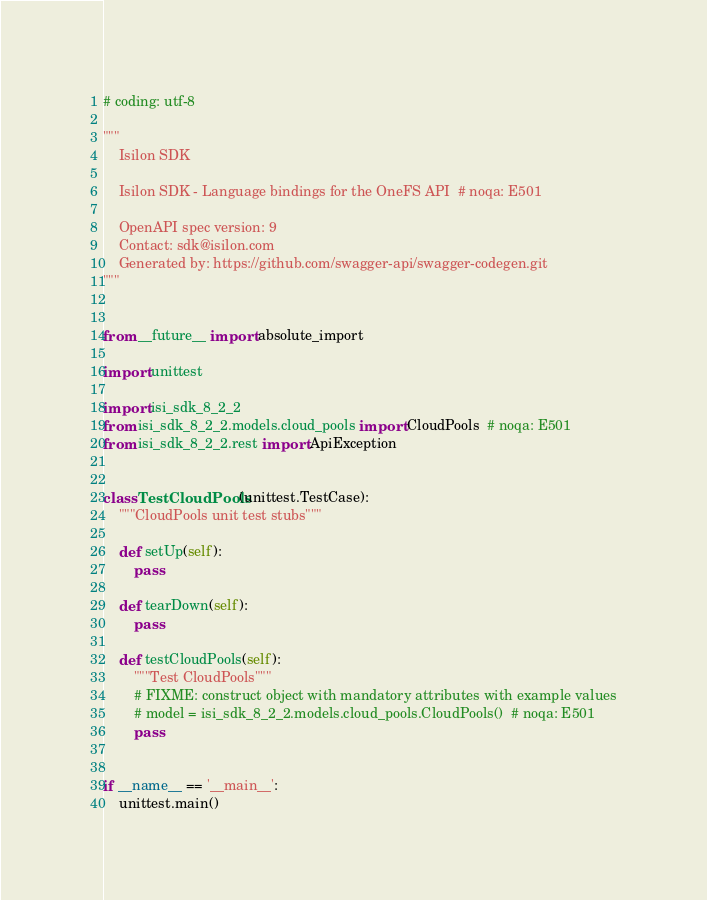<code> <loc_0><loc_0><loc_500><loc_500><_Python_># coding: utf-8

"""
    Isilon SDK

    Isilon SDK - Language bindings for the OneFS API  # noqa: E501

    OpenAPI spec version: 9
    Contact: sdk@isilon.com
    Generated by: https://github.com/swagger-api/swagger-codegen.git
"""


from __future__ import absolute_import

import unittest

import isi_sdk_8_2_2
from isi_sdk_8_2_2.models.cloud_pools import CloudPools  # noqa: E501
from isi_sdk_8_2_2.rest import ApiException


class TestCloudPools(unittest.TestCase):
    """CloudPools unit test stubs"""

    def setUp(self):
        pass

    def tearDown(self):
        pass

    def testCloudPools(self):
        """Test CloudPools"""
        # FIXME: construct object with mandatory attributes with example values
        # model = isi_sdk_8_2_2.models.cloud_pools.CloudPools()  # noqa: E501
        pass


if __name__ == '__main__':
    unittest.main()
</code> 